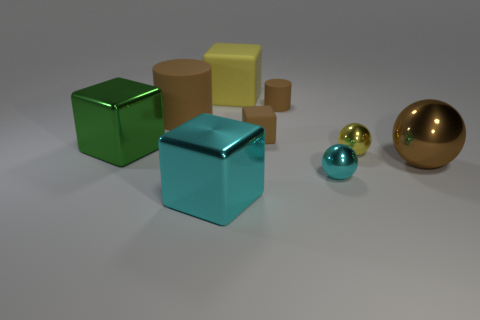Subtract all green shiny cubes. How many cubes are left? 3 Subtract all cyan blocks. How many blocks are left? 3 Subtract all balls. How many objects are left? 6 Subtract 2 blocks. How many blocks are left? 2 Add 3 tiny metal balls. How many tiny metal balls are left? 5 Add 8 tiny matte cylinders. How many tiny matte cylinders exist? 9 Subtract 1 brown blocks. How many objects are left? 8 Subtract all red blocks. Subtract all blue spheres. How many blocks are left? 4 Subtract all green blocks. Subtract all tiny gray metal cubes. How many objects are left? 8 